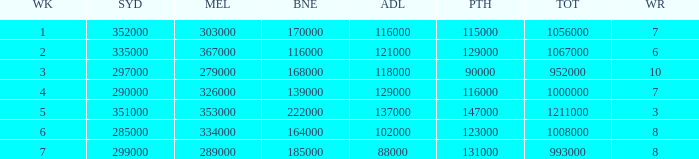How many episodes aired in Sydney in Week 3? 1.0. 